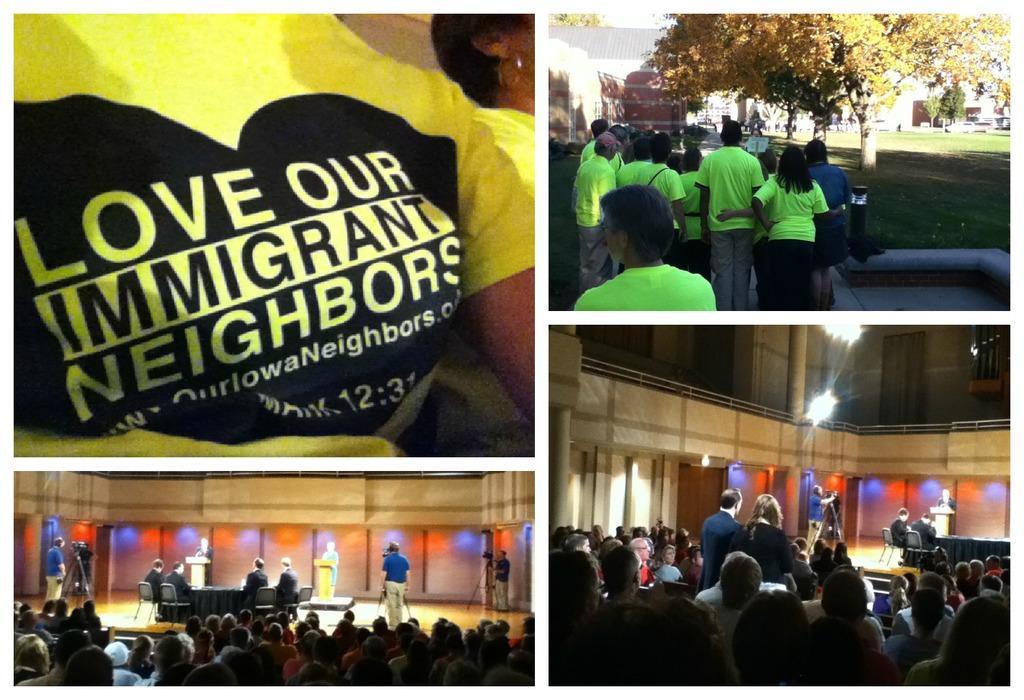Please provide a concise description of this image. This is the picture of a collage photo with four different photos and in the top left side, we can see a photo of a cloth with some text and in the bottom left we can see some people and among them two people are standing near podium on the stage and there are few people taking videos with cameras. On the top right side, we can see a photo of some people standing and there are some trees and buildings and in the bottom right side, we can see a photo of some people. 